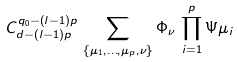Convert formula to latex. <formula><loc_0><loc_0><loc_500><loc_500>C _ { d - \left ( l - 1 \right ) p } ^ { q _ { 0 } - \left ( l - 1 \right ) p } \, \sum _ { \left \{ \mu _ { 1 } , \dots , \mu _ { p } , \nu \right \} } \Phi _ { \nu } \, \prod _ { i = 1 } ^ { p } \Psi \mu _ { i }</formula> 